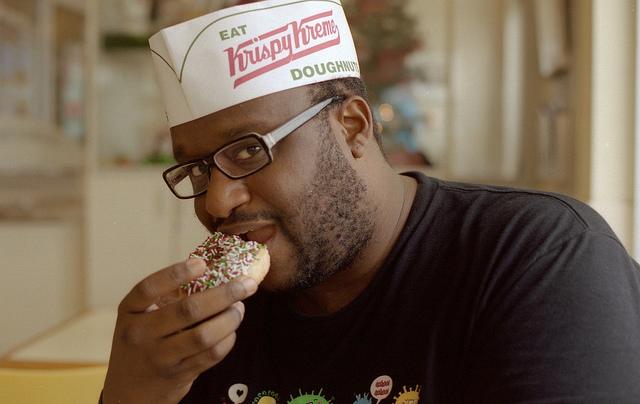What is affixed to his ear?
Quick response, please. Glasses. Is he on a phone?
Quick response, please. No. What is he holding?
Concise answer only. Donut. What is the person eating?
Write a very short answer. Donut. Which company does he work at?
Concise answer only. Krispy kreme. Is the man grasping the hot dog in his right hand?
Answer briefly. No. What is the man eating?
Answer briefly. Donut. Why does he cover one ear?
Quick response, please. He doesn't. What is the man holding?
Keep it brief. Donut. Is the man a construction worker?
Keep it brief. No. What color is the man's shirt?
Keep it brief. Black. What ethnicity is the man?
Be succinct. Black. Is this person wearing a tie?
Give a very brief answer. No. Is this a Caucasian person?
Keep it brief. No. Has the man recently shaved?
Quick response, please. No. How old is the boy?
Give a very brief answer. 30. Does this photo look out of focus?
Short answer required. No. Do you see toothpaste on his lips?
Keep it brief. No. Does the man have a cell phone?
Keep it brief. No. What is the man's right hand doing?
Give a very brief answer. Holding donut. Is the man blurry?
Short answer required. No. Is the man dressed in formal attire?
Be succinct. No. 